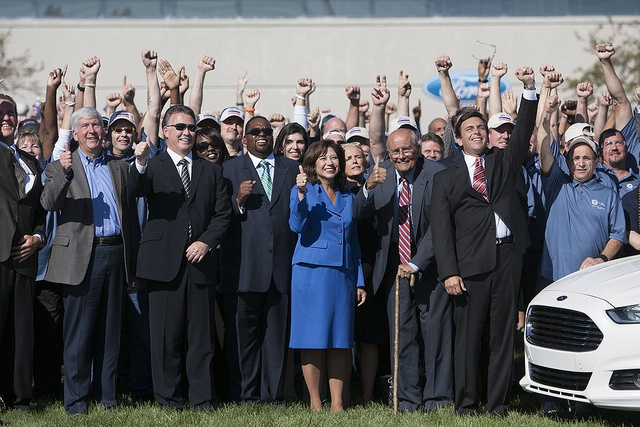Describe the objects in this image and their specific colors. I can see people in gray, black, and lightgray tones, people in gray, black, lightpink, and lightgray tones, people in gray, black, lightgray, and lightpink tones, people in gray, black, navy, and darkgray tones, and people in gray, blue, black, and navy tones in this image. 